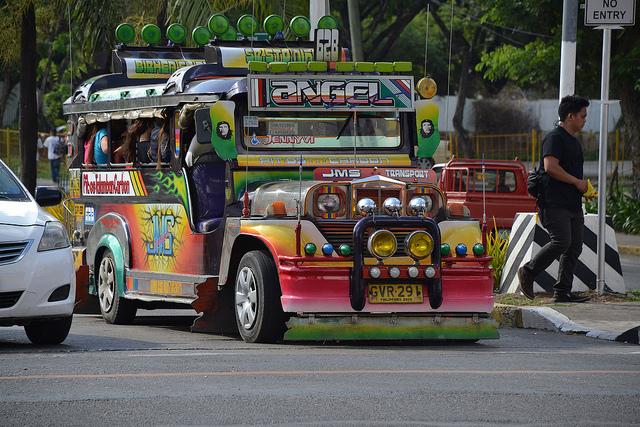Is this taken from the street?
Keep it brief. Yes. What object is multicolored?
Quick response, please. Bus. What word is over the windshield?
Write a very short answer. Angel. 